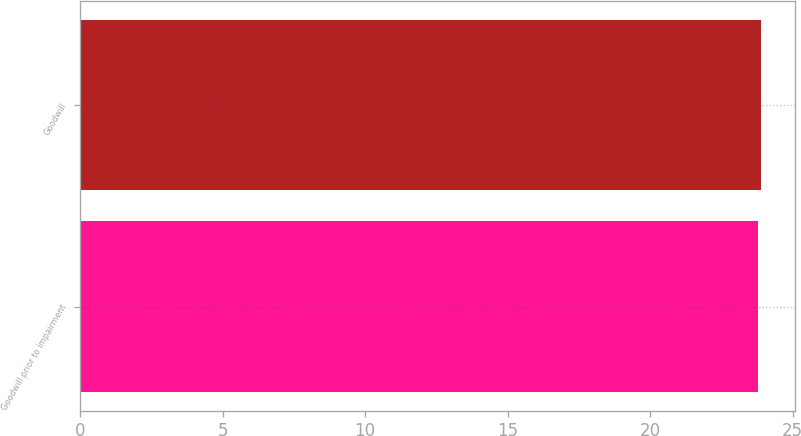Convert chart to OTSL. <chart><loc_0><loc_0><loc_500><loc_500><bar_chart><fcel>Goodwill prior to impairment<fcel>Goodwill<nl><fcel>23.8<fcel>23.9<nl></chart> 